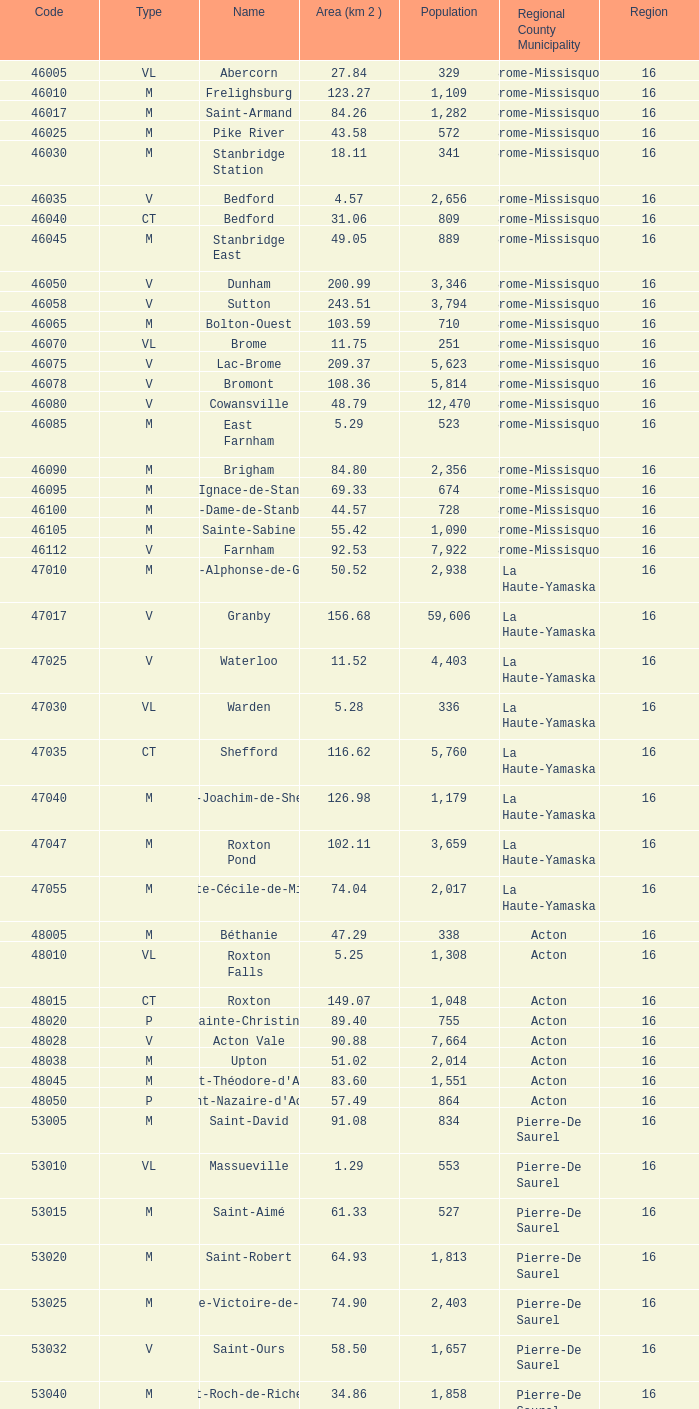Cowansville, having under 16 zones and being a brome-missisquoi municipality, what is the number of inhabitants? None. 